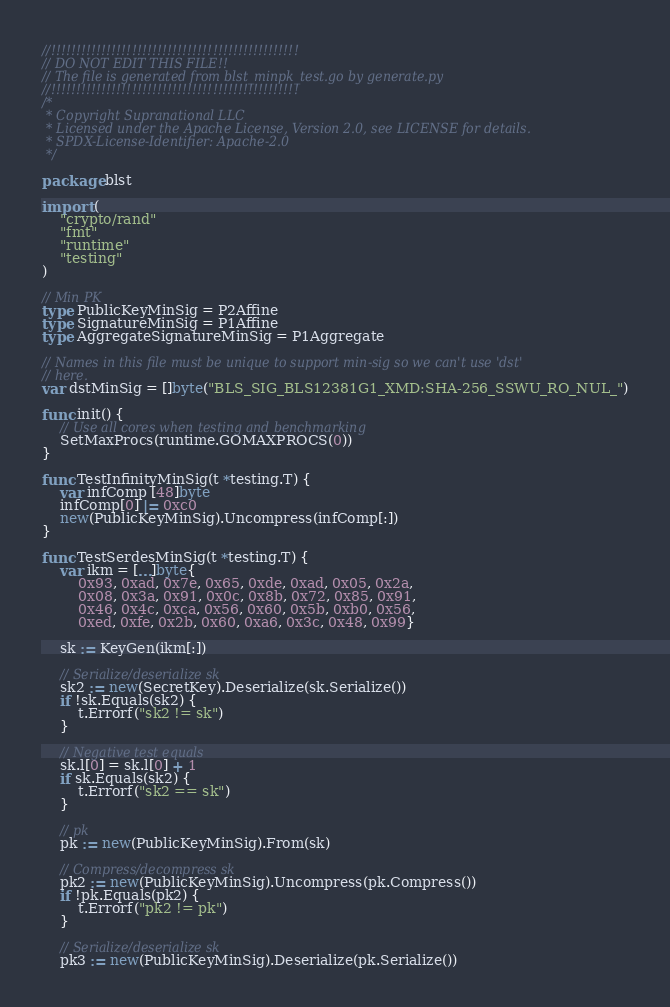Convert code to text. <code><loc_0><loc_0><loc_500><loc_500><_Go_>//!!!!!!!!!!!!!!!!!!!!!!!!!!!!!!!!!!!!!!!!!!!!!!!!!
// DO NOT EDIT THIS FILE!!
// The file is generated from blst_minpk_test.go by generate.py
//!!!!!!!!!!!!!!!!!!!!!!!!!!!!!!!!!!!!!!!!!!!!!!!!!
/*
 * Copyright Supranational LLC
 * Licensed under the Apache License, Version 2.0, see LICENSE for details.
 * SPDX-License-Identifier: Apache-2.0
 */

package blst

import (
	"crypto/rand"
	"fmt"
	"runtime"
	"testing"
)

// Min PK
type PublicKeyMinSig = P2Affine
type SignatureMinSig = P1Affine
type AggregateSignatureMinSig = P1Aggregate

// Names in this file must be unique to support min-sig so we can't use 'dst'
// here.
var dstMinSig = []byte("BLS_SIG_BLS12381G1_XMD:SHA-256_SSWU_RO_NUL_")

func init() {
	// Use all cores when testing and benchmarking
	SetMaxProcs(runtime.GOMAXPROCS(0))
}

func TestInfinityMinSig(t *testing.T) {
	var infComp [48]byte
	infComp[0] |= 0xc0
	new(PublicKeyMinSig).Uncompress(infComp[:])
}

func TestSerdesMinSig(t *testing.T) {
	var ikm = [...]byte{
		0x93, 0xad, 0x7e, 0x65, 0xde, 0xad, 0x05, 0x2a,
		0x08, 0x3a, 0x91, 0x0c, 0x8b, 0x72, 0x85, 0x91,
		0x46, 0x4c, 0xca, 0x56, 0x60, 0x5b, 0xb0, 0x56,
		0xed, 0xfe, 0x2b, 0x60, 0xa6, 0x3c, 0x48, 0x99}

	sk := KeyGen(ikm[:])

	// Serialize/deserialize sk
	sk2 := new(SecretKey).Deserialize(sk.Serialize())
	if !sk.Equals(sk2) {
		t.Errorf("sk2 != sk")
	}

	// Negative test equals
	sk.l[0] = sk.l[0] + 1
	if sk.Equals(sk2) {
		t.Errorf("sk2 == sk")
	}

	// pk
	pk := new(PublicKeyMinSig).From(sk)

	// Compress/decompress sk
	pk2 := new(PublicKeyMinSig).Uncompress(pk.Compress())
	if !pk.Equals(pk2) {
		t.Errorf("pk2 != pk")
	}

	// Serialize/deserialize sk
	pk3 := new(PublicKeyMinSig).Deserialize(pk.Serialize())</code> 